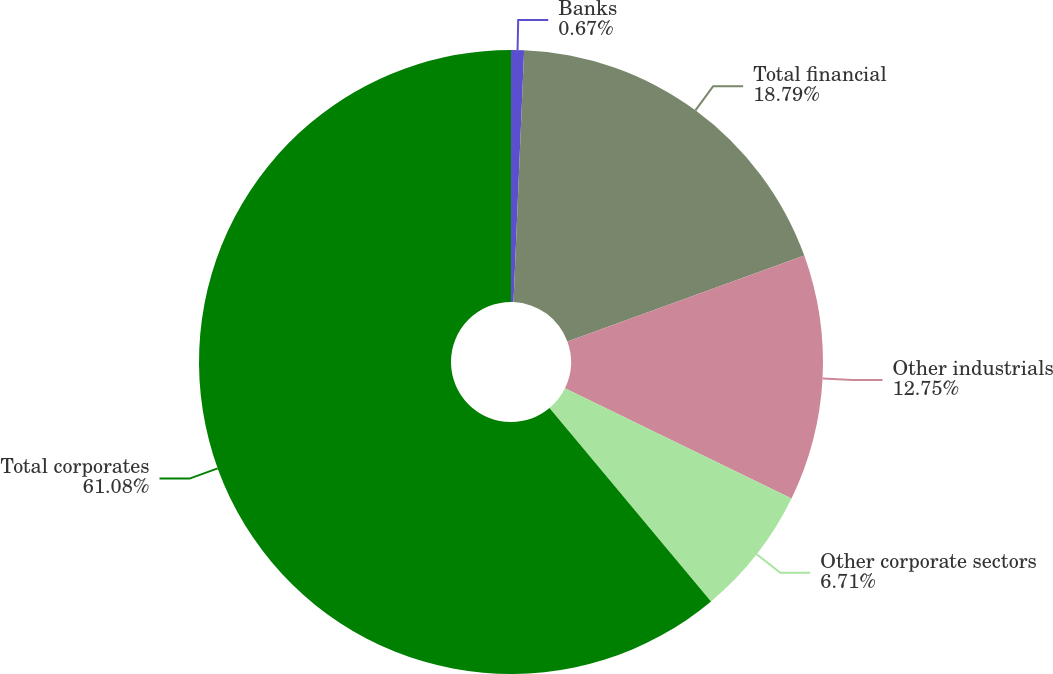Convert chart to OTSL. <chart><loc_0><loc_0><loc_500><loc_500><pie_chart><fcel>Banks<fcel>Total financial<fcel>Other industrials<fcel>Other corporate sectors<fcel>Total corporates<nl><fcel>0.67%<fcel>18.79%<fcel>12.75%<fcel>6.71%<fcel>61.07%<nl></chart> 